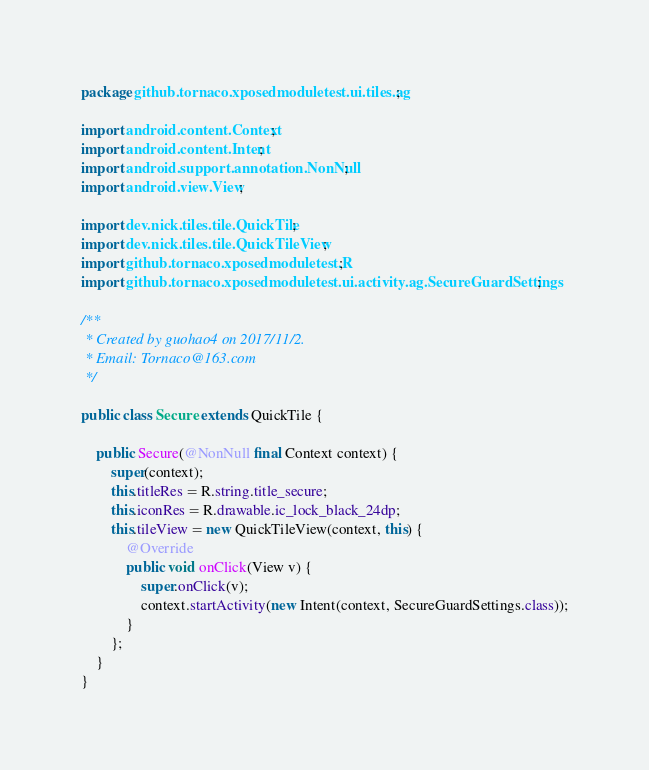<code> <loc_0><loc_0><loc_500><loc_500><_Java_>package github.tornaco.xposedmoduletest.ui.tiles.ag;

import android.content.Context;
import android.content.Intent;
import android.support.annotation.NonNull;
import android.view.View;

import dev.nick.tiles.tile.QuickTile;
import dev.nick.tiles.tile.QuickTileView;
import github.tornaco.xposedmoduletest.R;
import github.tornaco.xposedmoduletest.ui.activity.ag.SecureGuardSettings;

/**
 * Created by guohao4 on 2017/11/2.
 * Email: Tornaco@163.com
 */

public class Secure extends QuickTile {

    public Secure(@NonNull final Context context) {
        super(context);
        this.titleRes = R.string.title_secure;
        this.iconRes = R.drawable.ic_lock_black_24dp;
        this.tileView = new QuickTileView(context, this) {
            @Override
            public void onClick(View v) {
                super.onClick(v);
                context.startActivity(new Intent(context, SecureGuardSettings.class));
            }
        };
    }
}
</code> 